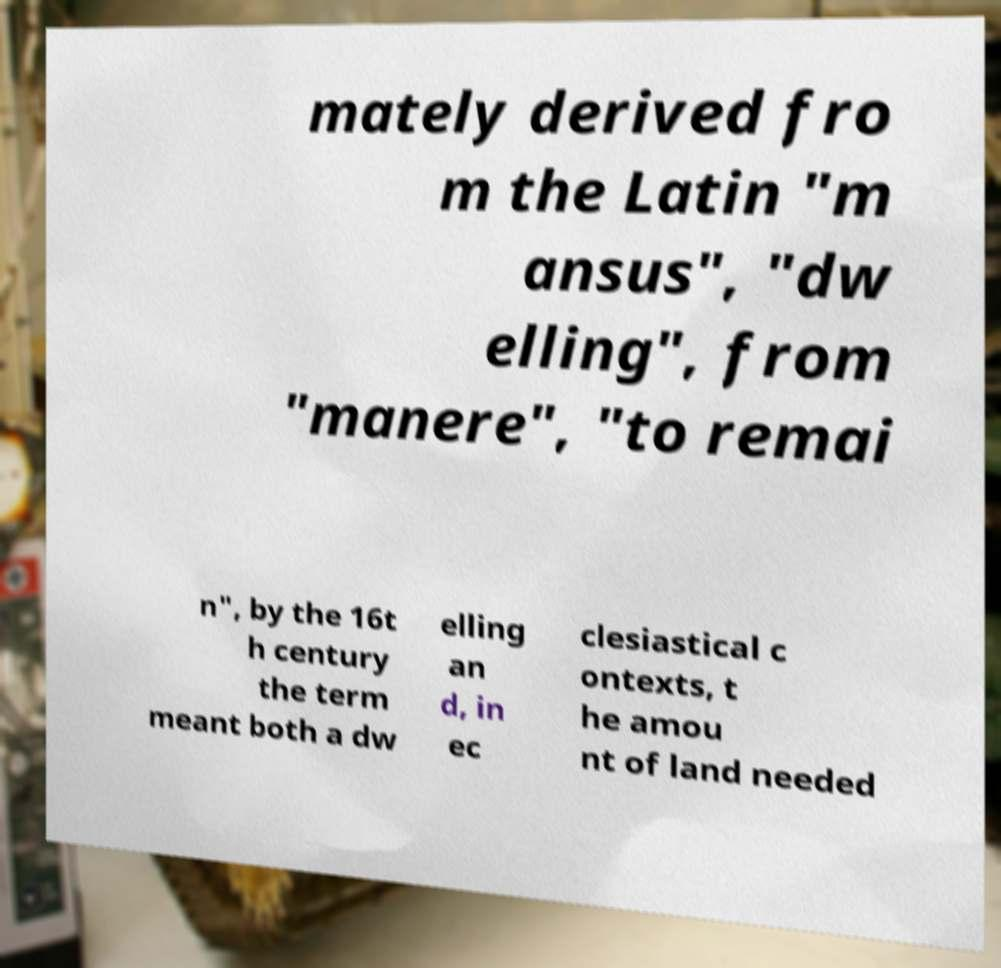I need the written content from this picture converted into text. Can you do that? mately derived fro m the Latin "m ansus", "dw elling", from "manere", "to remai n", by the 16t h century the term meant both a dw elling an d, in ec clesiastical c ontexts, t he amou nt of land needed 